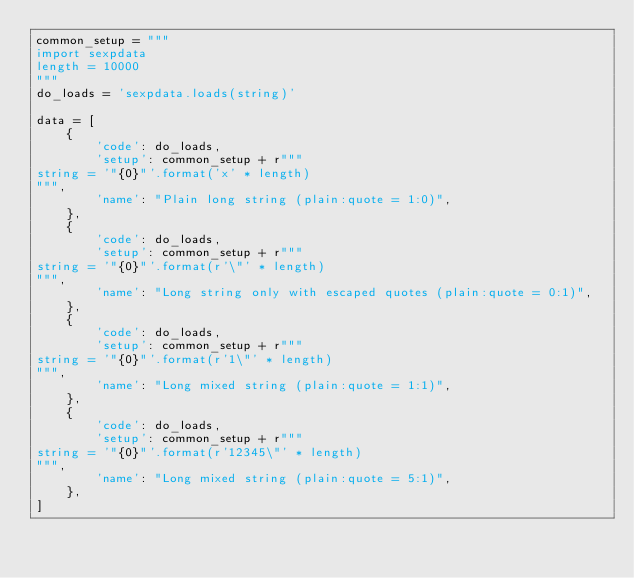<code> <loc_0><loc_0><loc_500><loc_500><_Python_>common_setup = """
import sexpdata
length = 10000
"""
do_loads = 'sexpdata.loads(string)'

data = [
    {
        'code': do_loads,
        'setup': common_setup + r"""
string = '"{0}"'.format('x' * length)
""",
        'name': "Plain long string (plain:quote = 1:0)",
    },
    {
        'code': do_loads,
        'setup': common_setup + r"""
string = '"{0}"'.format(r'\"' * length)
""",
        'name': "Long string only with escaped quotes (plain:quote = 0:1)",
    },
    {
        'code': do_loads,
        'setup': common_setup + r"""
string = '"{0}"'.format(r'1\"' * length)
""",
        'name': "Long mixed string (plain:quote = 1:1)",
    },
    {
        'code': do_loads,
        'setup': common_setup + r"""
string = '"{0}"'.format(r'12345\"' * length)
""",
        'name': "Long mixed string (plain:quote = 5:1)",
    },
]
</code> 